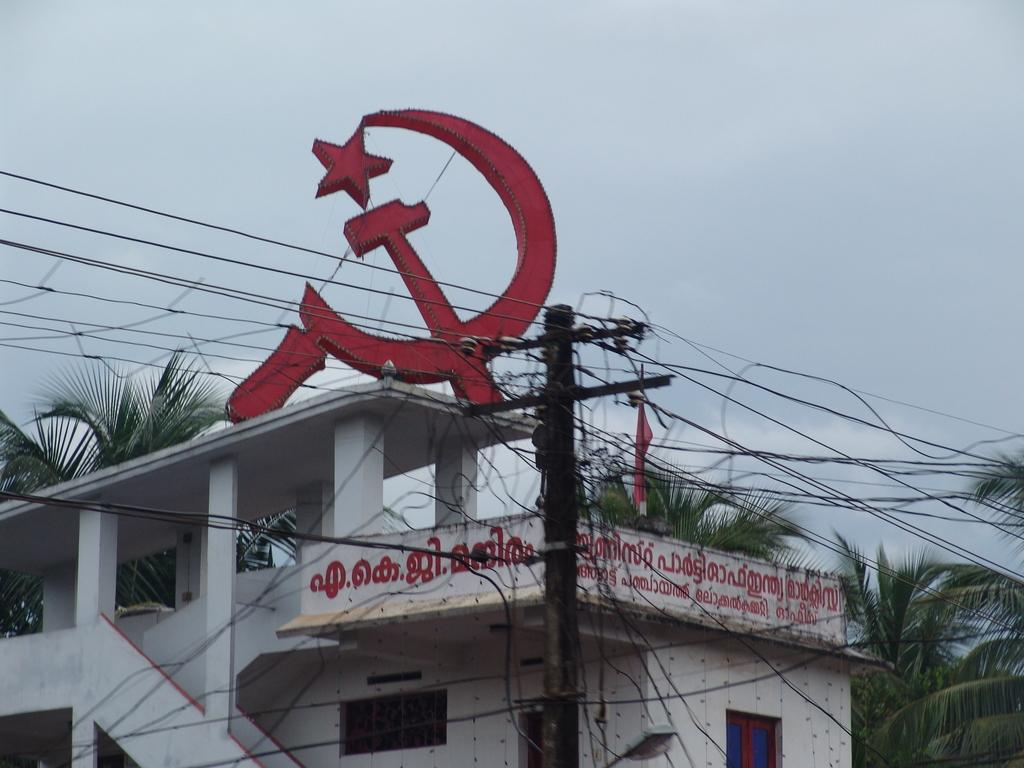What can be seen in the foreground of the picture? In the foreground of the picture, there are cables and a pole. What is located in the center of the picture? In the center of the picture, there are trees, a building, text, and a party logo. How would you describe the sky in the picture? The sky in the picture is cloudy. Can you tell me how many ducks are swimming in the building in the image? There are no ducks present in the image, and the building is not a body of water where ducks would swim. 